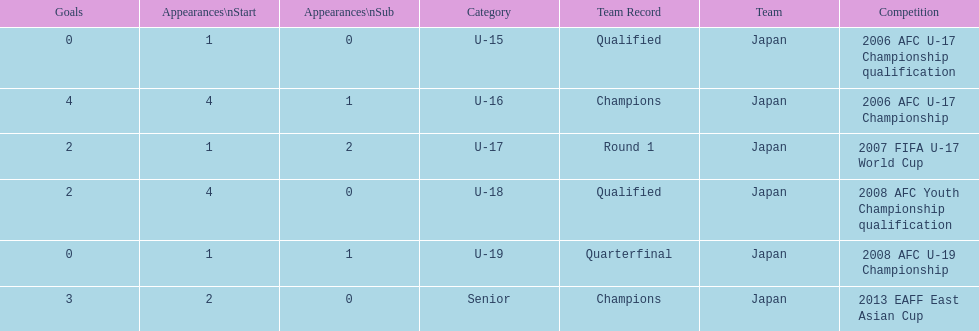What competition did japan compete in 2013? 2013 EAFF East Asian Cup. 